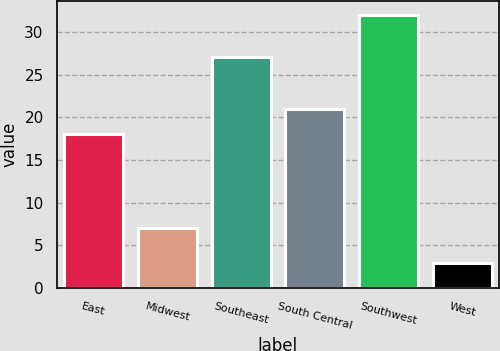Convert chart to OTSL. <chart><loc_0><loc_0><loc_500><loc_500><bar_chart><fcel>East<fcel>Midwest<fcel>Southeast<fcel>South Central<fcel>Southwest<fcel>West<nl><fcel>18<fcel>7<fcel>27<fcel>21<fcel>32<fcel>3<nl></chart> 